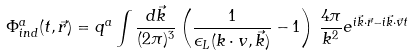<formula> <loc_0><loc_0><loc_500><loc_500>\Phi ^ { a } _ { i n d } ( t , \vec { r } ) = q ^ { a } \int \frac { d \vec { k } } { ( 2 \pi ) ^ { 3 } } \left ( \frac { 1 } { \epsilon _ { L } ( k \cdot v , \vec { k } ) } - 1 \right ) \, \frac { 4 \pi } { k ^ { 2 } } e ^ { i \vec { k } \cdot \vec { r } - i \vec { k } \cdot \vec { v } t }</formula> 